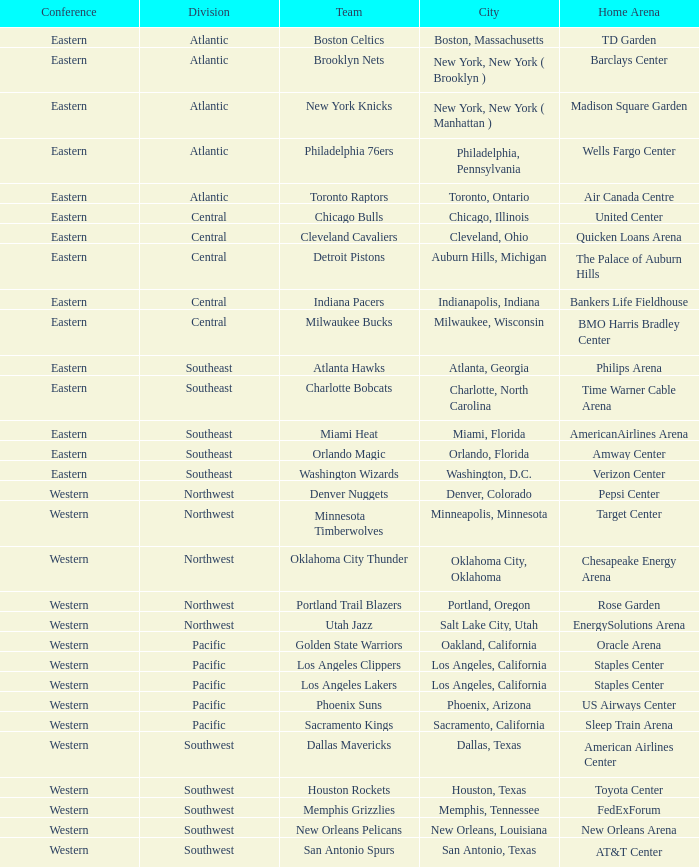Which municipality incorporates the target center arena? Minneapolis, Minnesota. Can you parse all the data within this table? {'header': ['Conference', 'Division', 'Team', 'City', 'Home Arena'], 'rows': [['Eastern', 'Atlantic', 'Boston Celtics', 'Boston, Massachusetts', 'TD Garden'], ['Eastern', 'Atlantic', 'Brooklyn Nets', 'New York, New York ( Brooklyn )', 'Barclays Center'], ['Eastern', 'Atlantic', 'New York Knicks', 'New York, New York ( Manhattan )', 'Madison Square Garden'], ['Eastern', 'Atlantic', 'Philadelphia 76ers', 'Philadelphia, Pennsylvania', 'Wells Fargo Center'], ['Eastern', 'Atlantic', 'Toronto Raptors', 'Toronto, Ontario', 'Air Canada Centre'], ['Eastern', 'Central', 'Chicago Bulls', 'Chicago, Illinois', 'United Center'], ['Eastern', 'Central', 'Cleveland Cavaliers', 'Cleveland, Ohio', 'Quicken Loans Arena'], ['Eastern', 'Central', 'Detroit Pistons', 'Auburn Hills, Michigan', 'The Palace of Auburn Hills'], ['Eastern', 'Central', 'Indiana Pacers', 'Indianapolis, Indiana', 'Bankers Life Fieldhouse'], ['Eastern', 'Central', 'Milwaukee Bucks', 'Milwaukee, Wisconsin', 'BMO Harris Bradley Center'], ['Eastern', 'Southeast', 'Atlanta Hawks', 'Atlanta, Georgia', 'Philips Arena'], ['Eastern', 'Southeast', 'Charlotte Bobcats', 'Charlotte, North Carolina', 'Time Warner Cable Arena'], ['Eastern', 'Southeast', 'Miami Heat', 'Miami, Florida', 'AmericanAirlines Arena'], ['Eastern', 'Southeast', 'Orlando Magic', 'Orlando, Florida', 'Amway Center'], ['Eastern', 'Southeast', 'Washington Wizards', 'Washington, D.C.', 'Verizon Center'], ['Western', 'Northwest', 'Denver Nuggets', 'Denver, Colorado', 'Pepsi Center'], ['Western', 'Northwest', 'Minnesota Timberwolves', 'Minneapolis, Minnesota', 'Target Center'], ['Western', 'Northwest', 'Oklahoma City Thunder', 'Oklahoma City, Oklahoma', 'Chesapeake Energy Arena'], ['Western', 'Northwest', 'Portland Trail Blazers', 'Portland, Oregon', 'Rose Garden'], ['Western', 'Northwest', 'Utah Jazz', 'Salt Lake City, Utah', 'EnergySolutions Arena'], ['Western', 'Pacific', 'Golden State Warriors', 'Oakland, California', 'Oracle Arena'], ['Western', 'Pacific', 'Los Angeles Clippers', 'Los Angeles, California', 'Staples Center'], ['Western', 'Pacific', 'Los Angeles Lakers', 'Los Angeles, California', 'Staples Center'], ['Western', 'Pacific', 'Phoenix Suns', 'Phoenix, Arizona', 'US Airways Center'], ['Western', 'Pacific', 'Sacramento Kings', 'Sacramento, California', 'Sleep Train Arena'], ['Western', 'Southwest', 'Dallas Mavericks', 'Dallas, Texas', 'American Airlines Center'], ['Western', 'Southwest', 'Houston Rockets', 'Houston, Texas', 'Toyota Center'], ['Western', 'Southwest', 'Memphis Grizzlies', 'Memphis, Tennessee', 'FedExForum'], ['Western', 'Southwest', 'New Orleans Pelicans', 'New Orleans, Louisiana', 'New Orleans Arena'], ['Western', 'Southwest', 'San Antonio Spurs', 'San Antonio, Texas', 'AT&T Center']]} 